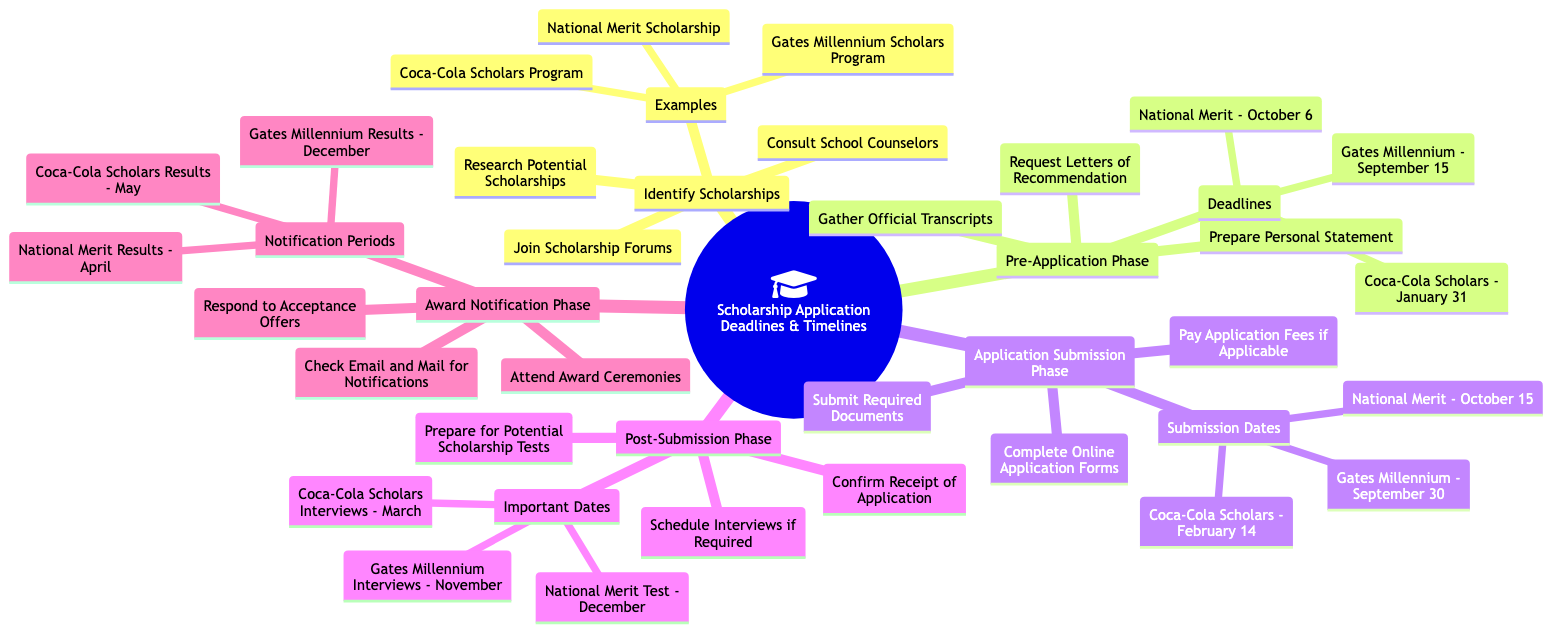What are the three steps in the Identify Scholarships phase? The Identify Scholarships phase includes researching potential scholarships, consulting school counselors, and joining scholarship forums. Each step can be found directly under this node in the diagram.
Answer: Research Potential Scholarships, Consult School Counselors, Join Scholarship Forums When is the deadline for the Coca-Cola Scholars application? The deadline for the Coca-Cola Scholars application can be found in the Pre-Application Phase, which lists the deadlines for several scholarships. The specific date mentioned is January 31.
Answer: January 31 How many components are listed in the Application Submission Phase? In the Application Submission Phase, there are three components: completing online application forms, submitting required documents, and paying application fees if applicable. This count is derived by directly counting the listed components within this phase.
Answer: 3 What date are the Coca-Cola Scholars results announced? The notification periods for the results of the Coca-Cola Scholars are detailed in the Award Notification Phase, which specifies that results are announced in May.
Answer: May Which scholarship has the latest notification period? To determine the scholarship with the latest notification period, we can compare the notification periods listed for each scholarship. The Gates Millennium results are announced in December, which is the latest date when compared to Coca-Cola Scholars in May and National Merit in April.
Answer: Gates Millennium What is the first task in the Post-Submission Phase? In the Post-Submission Phase, the first task listed is to confirm the receipt of the application. This is identified by looking at the order of tasks provided in this section of the mind map.
Answer: Confirm Receipt of Application Which scholarship requires a test in December? The National Merit Test is scheduled for December, as mentioned in the important dates listed under the Post-Submission Phase. By locating the relevant date against the scholarship names, we identify this answer.
Answer: National Merit Test What is required in the Pre-Application Phase along with letters of recommendation? Besides letters of recommendation, the Pre-Application Phase also requires preparing a personal statement and gathering official transcripts. These requirements can be found listed under the same phase in the diagram.
Answer: Prepare Personal Statement, Gather Official Transcripts Which phase includes confirming receipt of the application? The action of confirming the receipt of the application is included in the Post-Submission Phase, as it is the first task listed there. This information is straightforwardly extracted from the structure of the mind map.
Answer: Post-Submission Phase 